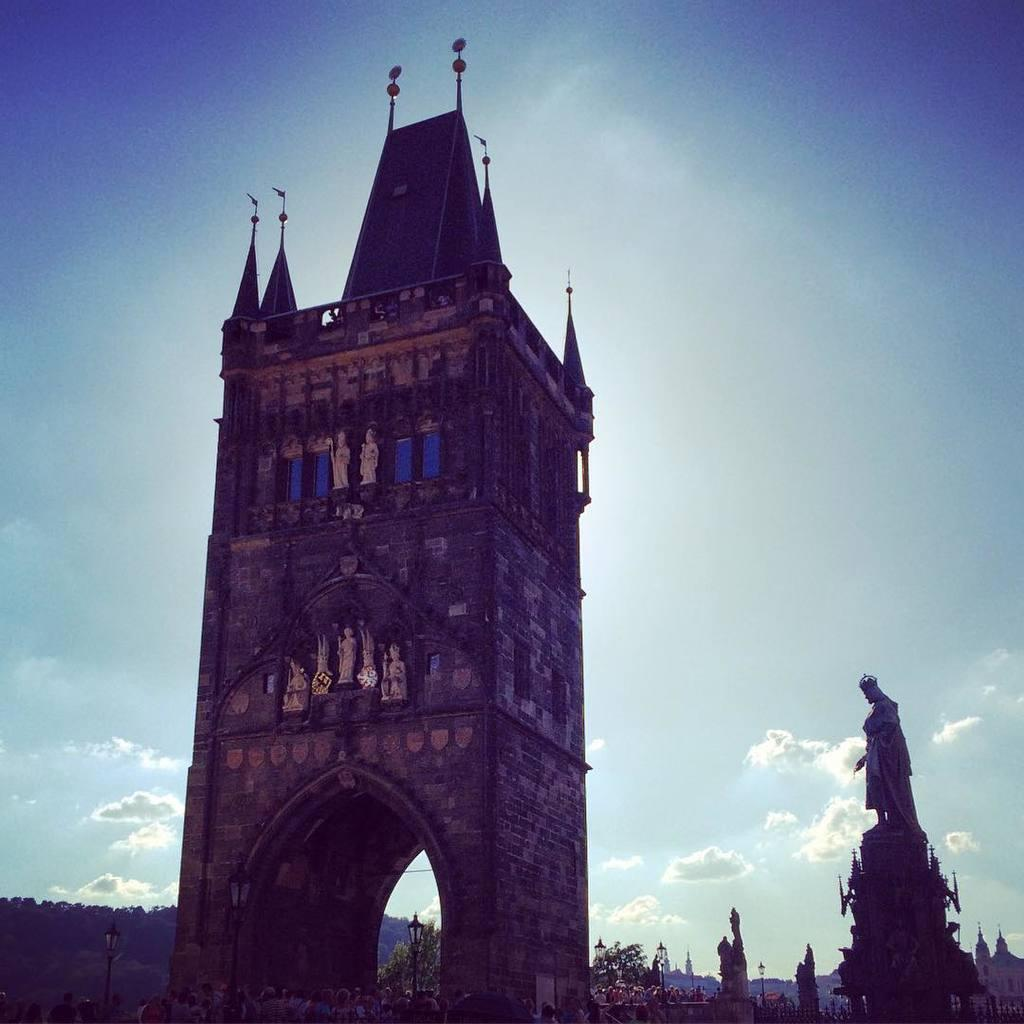What type of structure is visible in the image? There is a building in the image. What architectural feature can be seen at the bottom of the building? There is an arch at the bottom of the building. What type of vegetation is present on both sides of the image? There are trees on the left side and right side of the image. What can be seen in the sky in the background of the image? There are clouds in the sky in the background of the image. What type of organization is represented by the plate in the image? There is no plate present in the image, so it is not possible to determine what type of organization might be represented. 